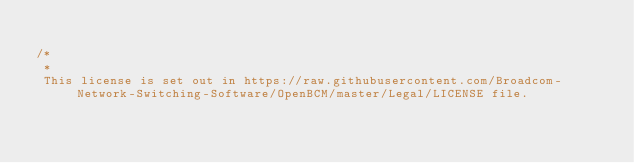Convert code to text. <code><loc_0><loc_0><loc_500><loc_500><_C_>
/*
 * 
 This license is set out in https://raw.githubusercontent.com/Broadcom-Network-Switching-Software/OpenBCM/master/Legal/LICENSE file.
 </code> 